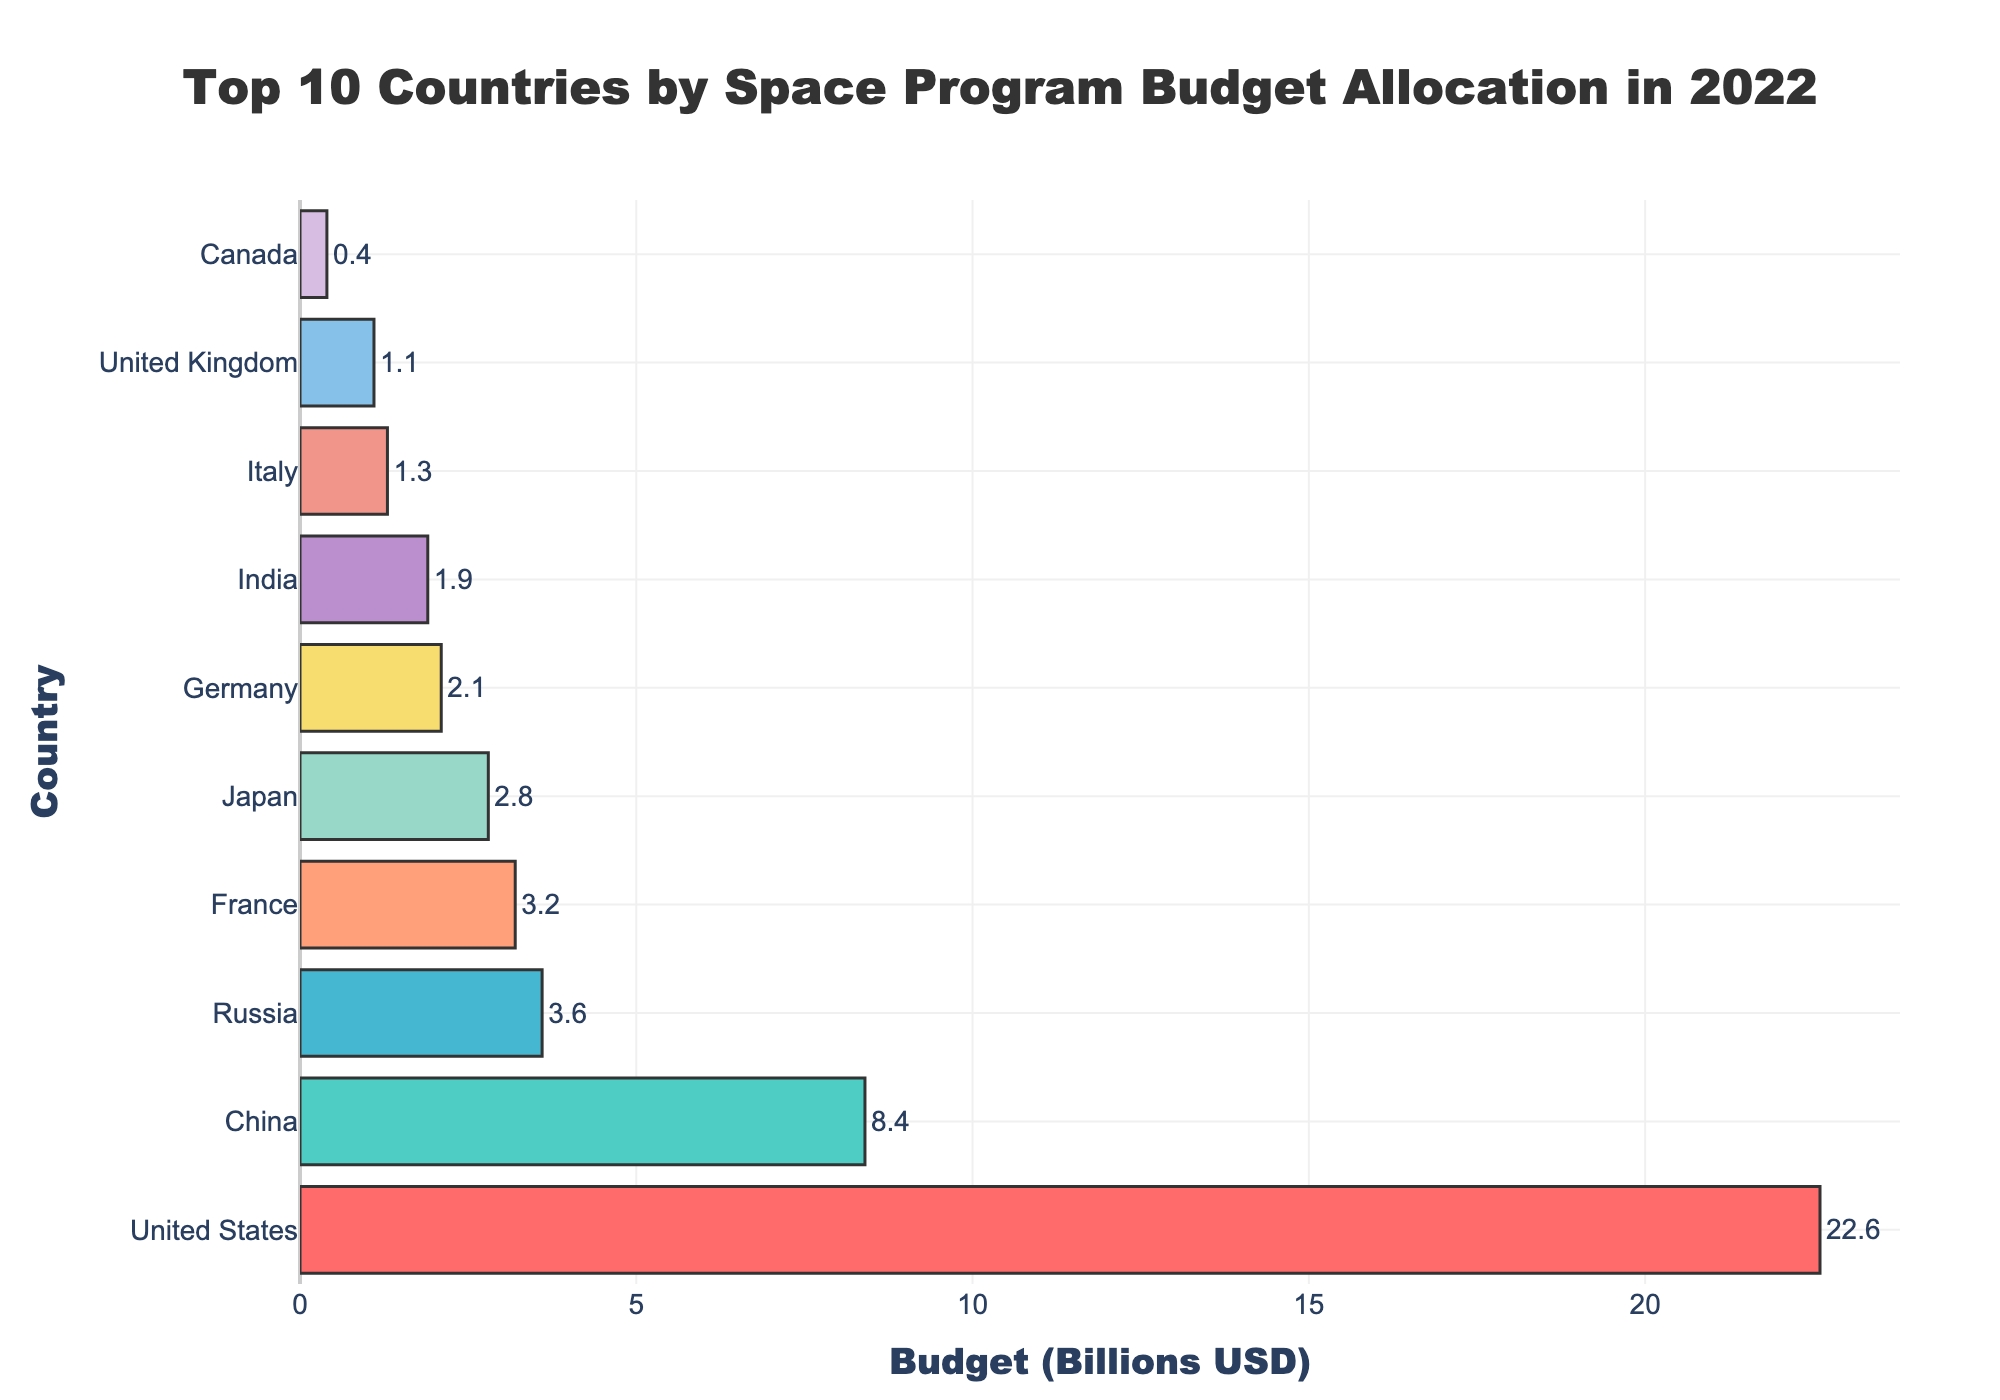What is the total budget allocated by the top 10 countries? To find the total budget, sum up the budgets of all 10 countries. Adding them up: 22.6 + 8.4 + 3.6 + 3.2 + 2.8 + 2.1 + 1.9 + 1.3 + 1.1 + 0.4 = 47.4
Answer: 47.4 Which country has the highest budget allocation for its space program? By looking at the figure, the longest bar represents the country with the highest budget. The United States has the highest budget of 22.6 billion USD.
Answer: United States How much more does the United States spend on its space program compared to China? Subtract China's budget from the United States' budget: 22.6 - 8.4 = 14.2. The United States spends 14.2 billion USD more than China.
Answer: 14.2 What is the average budget allocation among the top 10 countries? To find the average, sum up all the budgets and then divide by the number of countries. Total budget = 47.4; Number of countries = 10. Average = 47.4 / 10 = 4.74
Answer: 4.74 Which countries spend less than 2 billion USD on their space programs? By observing the bars, we identify countries with a budget below 2 billion USD: Italy (1.3), United Kingdom (1.1), Canada (0.4).
Answer: Italy, United Kingdom, Canada What is the combined budget for France and Japan? Add the budgets of France and Japan: 3.2 + 2.8 = 6.0. The combined budget for France and Japan is 6.0 billion USD.
Answer: 6.0 How does Germany’s budget compare to Canada’s? By comparing the bar lengths, Germany's budget (2.1 billion USD) is significantly higher than Canada’s budget (0.4 billion USD).
Answer: Germany's budget is higher What percentage of the total budget is allocated by India? To find the percentage, divide India's budget by the total budget and multiply by 100: (1.9 / 47.4) * 100 ≈ 4.0%.
Answer: ~4.0% Which country ranks third in terms of budget allocation? By arranging the countries based on the bar lengths, we see that Russia has the third-highest budget allocation at 3.6 billion USD.
Answer: Russia How much less does the United Kingdom spend compared to Germany? Subtract the United Kingdom's budget from Germany's budget: 2.1 - 1.1 = 1.0. The United Kingdom spends 1.0 billion USD less than Germany.
Answer: 1.0 